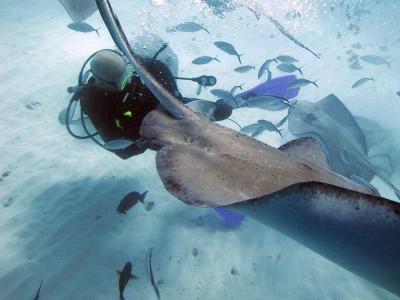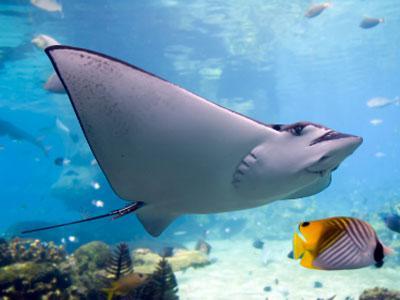The first image is the image on the left, the second image is the image on the right. Analyze the images presented: Is the assertion "In the left photo, there is a woman kneeling on the ocean floor touching a manta ray." valid? Answer yes or no. No. 